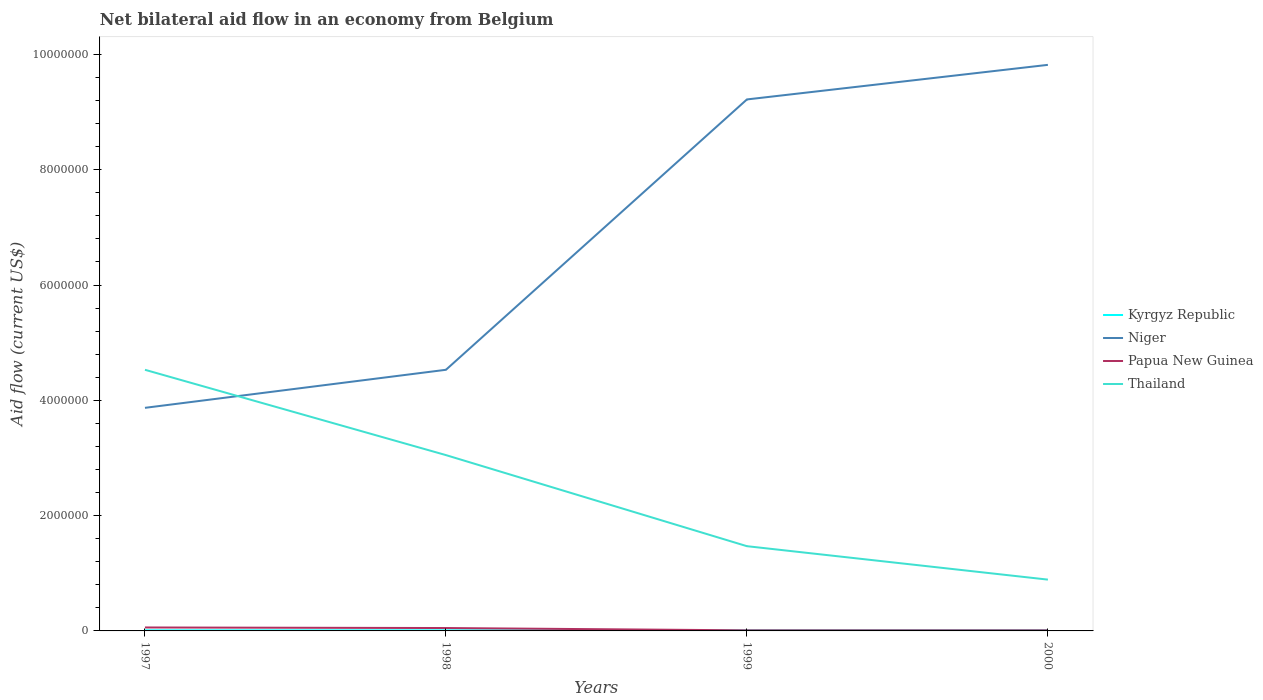How many different coloured lines are there?
Make the answer very short. 4. Is the number of lines equal to the number of legend labels?
Offer a very short reply. Yes. Across all years, what is the maximum net bilateral aid flow in Thailand?
Your answer should be very brief. 8.90e+05. Is the net bilateral aid flow in Niger strictly greater than the net bilateral aid flow in Thailand over the years?
Ensure brevity in your answer.  No. How many lines are there?
Your answer should be compact. 4. How many legend labels are there?
Provide a succinct answer. 4. What is the title of the graph?
Ensure brevity in your answer.  Net bilateral aid flow in an economy from Belgium. Does "Uzbekistan" appear as one of the legend labels in the graph?
Keep it short and to the point. No. What is the label or title of the Y-axis?
Offer a terse response. Aid flow (current US$). What is the Aid flow (current US$) in Niger in 1997?
Keep it short and to the point. 3.87e+06. What is the Aid flow (current US$) of Papua New Guinea in 1997?
Make the answer very short. 6.00e+04. What is the Aid flow (current US$) of Thailand in 1997?
Your answer should be compact. 4.53e+06. What is the Aid flow (current US$) of Kyrgyz Republic in 1998?
Give a very brief answer. 10000. What is the Aid flow (current US$) of Niger in 1998?
Keep it short and to the point. 4.53e+06. What is the Aid flow (current US$) of Thailand in 1998?
Keep it short and to the point. 3.05e+06. What is the Aid flow (current US$) of Kyrgyz Republic in 1999?
Keep it short and to the point. 10000. What is the Aid flow (current US$) in Niger in 1999?
Your response must be concise. 9.22e+06. What is the Aid flow (current US$) in Papua New Guinea in 1999?
Provide a succinct answer. 10000. What is the Aid flow (current US$) of Thailand in 1999?
Give a very brief answer. 1.47e+06. What is the Aid flow (current US$) in Kyrgyz Republic in 2000?
Your response must be concise. 10000. What is the Aid flow (current US$) of Niger in 2000?
Offer a terse response. 9.82e+06. What is the Aid flow (current US$) in Papua New Guinea in 2000?
Offer a terse response. 10000. What is the Aid flow (current US$) of Thailand in 2000?
Give a very brief answer. 8.90e+05. Across all years, what is the maximum Aid flow (current US$) of Niger?
Offer a very short reply. 9.82e+06. Across all years, what is the maximum Aid flow (current US$) of Papua New Guinea?
Provide a short and direct response. 6.00e+04. Across all years, what is the maximum Aid flow (current US$) in Thailand?
Make the answer very short. 4.53e+06. Across all years, what is the minimum Aid flow (current US$) of Niger?
Ensure brevity in your answer.  3.87e+06. Across all years, what is the minimum Aid flow (current US$) in Thailand?
Offer a terse response. 8.90e+05. What is the total Aid flow (current US$) of Kyrgyz Republic in the graph?
Keep it short and to the point. 4.00e+04. What is the total Aid flow (current US$) of Niger in the graph?
Provide a short and direct response. 2.74e+07. What is the total Aid flow (current US$) in Thailand in the graph?
Offer a very short reply. 9.94e+06. What is the difference between the Aid flow (current US$) in Niger in 1997 and that in 1998?
Make the answer very short. -6.60e+05. What is the difference between the Aid flow (current US$) of Thailand in 1997 and that in 1998?
Make the answer very short. 1.48e+06. What is the difference between the Aid flow (current US$) in Kyrgyz Republic in 1997 and that in 1999?
Provide a succinct answer. 0. What is the difference between the Aid flow (current US$) of Niger in 1997 and that in 1999?
Make the answer very short. -5.35e+06. What is the difference between the Aid flow (current US$) of Papua New Guinea in 1997 and that in 1999?
Your response must be concise. 5.00e+04. What is the difference between the Aid flow (current US$) of Thailand in 1997 and that in 1999?
Offer a terse response. 3.06e+06. What is the difference between the Aid flow (current US$) in Kyrgyz Republic in 1997 and that in 2000?
Provide a short and direct response. 0. What is the difference between the Aid flow (current US$) of Niger in 1997 and that in 2000?
Provide a short and direct response. -5.95e+06. What is the difference between the Aid flow (current US$) in Papua New Guinea in 1997 and that in 2000?
Make the answer very short. 5.00e+04. What is the difference between the Aid flow (current US$) in Thailand in 1997 and that in 2000?
Ensure brevity in your answer.  3.64e+06. What is the difference between the Aid flow (current US$) in Kyrgyz Republic in 1998 and that in 1999?
Provide a short and direct response. 0. What is the difference between the Aid flow (current US$) in Niger in 1998 and that in 1999?
Offer a very short reply. -4.69e+06. What is the difference between the Aid flow (current US$) in Thailand in 1998 and that in 1999?
Provide a succinct answer. 1.58e+06. What is the difference between the Aid flow (current US$) in Niger in 1998 and that in 2000?
Your response must be concise. -5.29e+06. What is the difference between the Aid flow (current US$) in Papua New Guinea in 1998 and that in 2000?
Your response must be concise. 4.00e+04. What is the difference between the Aid flow (current US$) of Thailand in 1998 and that in 2000?
Keep it short and to the point. 2.16e+06. What is the difference between the Aid flow (current US$) in Niger in 1999 and that in 2000?
Keep it short and to the point. -6.00e+05. What is the difference between the Aid flow (current US$) of Papua New Guinea in 1999 and that in 2000?
Keep it short and to the point. 0. What is the difference between the Aid flow (current US$) of Thailand in 1999 and that in 2000?
Offer a terse response. 5.80e+05. What is the difference between the Aid flow (current US$) of Kyrgyz Republic in 1997 and the Aid flow (current US$) of Niger in 1998?
Provide a short and direct response. -4.52e+06. What is the difference between the Aid flow (current US$) in Kyrgyz Republic in 1997 and the Aid flow (current US$) in Papua New Guinea in 1998?
Give a very brief answer. -4.00e+04. What is the difference between the Aid flow (current US$) in Kyrgyz Republic in 1997 and the Aid flow (current US$) in Thailand in 1998?
Your response must be concise. -3.04e+06. What is the difference between the Aid flow (current US$) in Niger in 1997 and the Aid flow (current US$) in Papua New Guinea in 1998?
Your answer should be compact. 3.82e+06. What is the difference between the Aid flow (current US$) in Niger in 1997 and the Aid flow (current US$) in Thailand in 1998?
Give a very brief answer. 8.20e+05. What is the difference between the Aid flow (current US$) in Papua New Guinea in 1997 and the Aid flow (current US$) in Thailand in 1998?
Your answer should be compact. -2.99e+06. What is the difference between the Aid flow (current US$) of Kyrgyz Republic in 1997 and the Aid flow (current US$) of Niger in 1999?
Your response must be concise. -9.21e+06. What is the difference between the Aid flow (current US$) of Kyrgyz Republic in 1997 and the Aid flow (current US$) of Thailand in 1999?
Your answer should be compact. -1.46e+06. What is the difference between the Aid flow (current US$) of Niger in 1997 and the Aid flow (current US$) of Papua New Guinea in 1999?
Your answer should be very brief. 3.86e+06. What is the difference between the Aid flow (current US$) of Niger in 1997 and the Aid flow (current US$) of Thailand in 1999?
Provide a succinct answer. 2.40e+06. What is the difference between the Aid flow (current US$) of Papua New Guinea in 1997 and the Aid flow (current US$) of Thailand in 1999?
Your response must be concise. -1.41e+06. What is the difference between the Aid flow (current US$) in Kyrgyz Republic in 1997 and the Aid flow (current US$) in Niger in 2000?
Give a very brief answer. -9.81e+06. What is the difference between the Aid flow (current US$) of Kyrgyz Republic in 1997 and the Aid flow (current US$) of Thailand in 2000?
Your response must be concise. -8.80e+05. What is the difference between the Aid flow (current US$) of Niger in 1997 and the Aid flow (current US$) of Papua New Guinea in 2000?
Ensure brevity in your answer.  3.86e+06. What is the difference between the Aid flow (current US$) of Niger in 1997 and the Aid flow (current US$) of Thailand in 2000?
Provide a succinct answer. 2.98e+06. What is the difference between the Aid flow (current US$) of Papua New Guinea in 1997 and the Aid flow (current US$) of Thailand in 2000?
Make the answer very short. -8.30e+05. What is the difference between the Aid flow (current US$) of Kyrgyz Republic in 1998 and the Aid flow (current US$) of Niger in 1999?
Offer a terse response. -9.21e+06. What is the difference between the Aid flow (current US$) of Kyrgyz Republic in 1998 and the Aid flow (current US$) of Thailand in 1999?
Your answer should be compact. -1.46e+06. What is the difference between the Aid flow (current US$) in Niger in 1998 and the Aid flow (current US$) in Papua New Guinea in 1999?
Provide a succinct answer. 4.52e+06. What is the difference between the Aid flow (current US$) in Niger in 1998 and the Aid flow (current US$) in Thailand in 1999?
Your answer should be compact. 3.06e+06. What is the difference between the Aid flow (current US$) in Papua New Guinea in 1998 and the Aid flow (current US$) in Thailand in 1999?
Make the answer very short. -1.42e+06. What is the difference between the Aid flow (current US$) in Kyrgyz Republic in 1998 and the Aid flow (current US$) in Niger in 2000?
Your answer should be very brief. -9.81e+06. What is the difference between the Aid flow (current US$) of Kyrgyz Republic in 1998 and the Aid flow (current US$) of Thailand in 2000?
Provide a succinct answer. -8.80e+05. What is the difference between the Aid flow (current US$) in Niger in 1998 and the Aid flow (current US$) in Papua New Guinea in 2000?
Your answer should be compact. 4.52e+06. What is the difference between the Aid flow (current US$) of Niger in 1998 and the Aid flow (current US$) of Thailand in 2000?
Your answer should be compact. 3.64e+06. What is the difference between the Aid flow (current US$) in Papua New Guinea in 1998 and the Aid flow (current US$) in Thailand in 2000?
Provide a short and direct response. -8.40e+05. What is the difference between the Aid flow (current US$) in Kyrgyz Republic in 1999 and the Aid flow (current US$) in Niger in 2000?
Give a very brief answer. -9.81e+06. What is the difference between the Aid flow (current US$) of Kyrgyz Republic in 1999 and the Aid flow (current US$) of Thailand in 2000?
Give a very brief answer. -8.80e+05. What is the difference between the Aid flow (current US$) in Niger in 1999 and the Aid flow (current US$) in Papua New Guinea in 2000?
Provide a succinct answer. 9.21e+06. What is the difference between the Aid flow (current US$) of Niger in 1999 and the Aid flow (current US$) of Thailand in 2000?
Your answer should be very brief. 8.33e+06. What is the difference between the Aid flow (current US$) of Papua New Guinea in 1999 and the Aid flow (current US$) of Thailand in 2000?
Offer a very short reply. -8.80e+05. What is the average Aid flow (current US$) of Kyrgyz Republic per year?
Your answer should be compact. 10000. What is the average Aid flow (current US$) of Niger per year?
Offer a terse response. 6.86e+06. What is the average Aid flow (current US$) of Papua New Guinea per year?
Your answer should be very brief. 3.25e+04. What is the average Aid flow (current US$) of Thailand per year?
Provide a short and direct response. 2.48e+06. In the year 1997, what is the difference between the Aid flow (current US$) in Kyrgyz Republic and Aid flow (current US$) in Niger?
Your response must be concise. -3.86e+06. In the year 1997, what is the difference between the Aid flow (current US$) in Kyrgyz Republic and Aid flow (current US$) in Thailand?
Keep it short and to the point. -4.52e+06. In the year 1997, what is the difference between the Aid flow (current US$) in Niger and Aid flow (current US$) in Papua New Guinea?
Your response must be concise. 3.81e+06. In the year 1997, what is the difference between the Aid flow (current US$) of Niger and Aid flow (current US$) of Thailand?
Your response must be concise. -6.60e+05. In the year 1997, what is the difference between the Aid flow (current US$) of Papua New Guinea and Aid flow (current US$) of Thailand?
Make the answer very short. -4.47e+06. In the year 1998, what is the difference between the Aid flow (current US$) of Kyrgyz Republic and Aid flow (current US$) of Niger?
Make the answer very short. -4.52e+06. In the year 1998, what is the difference between the Aid flow (current US$) in Kyrgyz Republic and Aid flow (current US$) in Papua New Guinea?
Provide a short and direct response. -4.00e+04. In the year 1998, what is the difference between the Aid flow (current US$) in Kyrgyz Republic and Aid flow (current US$) in Thailand?
Your response must be concise. -3.04e+06. In the year 1998, what is the difference between the Aid flow (current US$) of Niger and Aid flow (current US$) of Papua New Guinea?
Your answer should be very brief. 4.48e+06. In the year 1998, what is the difference between the Aid flow (current US$) of Niger and Aid flow (current US$) of Thailand?
Keep it short and to the point. 1.48e+06. In the year 1998, what is the difference between the Aid flow (current US$) in Papua New Guinea and Aid flow (current US$) in Thailand?
Your answer should be compact. -3.00e+06. In the year 1999, what is the difference between the Aid flow (current US$) in Kyrgyz Republic and Aid flow (current US$) in Niger?
Offer a very short reply. -9.21e+06. In the year 1999, what is the difference between the Aid flow (current US$) in Kyrgyz Republic and Aid flow (current US$) in Papua New Guinea?
Ensure brevity in your answer.  0. In the year 1999, what is the difference between the Aid flow (current US$) in Kyrgyz Republic and Aid flow (current US$) in Thailand?
Keep it short and to the point. -1.46e+06. In the year 1999, what is the difference between the Aid flow (current US$) of Niger and Aid flow (current US$) of Papua New Guinea?
Offer a very short reply. 9.21e+06. In the year 1999, what is the difference between the Aid flow (current US$) of Niger and Aid flow (current US$) of Thailand?
Provide a succinct answer. 7.75e+06. In the year 1999, what is the difference between the Aid flow (current US$) in Papua New Guinea and Aid flow (current US$) in Thailand?
Ensure brevity in your answer.  -1.46e+06. In the year 2000, what is the difference between the Aid flow (current US$) of Kyrgyz Republic and Aid flow (current US$) of Niger?
Make the answer very short. -9.81e+06. In the year 2000, what is the difference between the Aid flow (current US$) of Kyrgyz Republic and Aid flow (current US$) of Thailand?
Give a very brief answer. -8.80e+05. In the year 2000, what is the difference between the Aid flow (current US$) in Niger and Aid flow (current US$) in Papua New Guinea?
Make the answer very short. 9.81e+06. In the year 2000, what is the difference between the Aid flow (current US$) of Niger and Aid flow (current US$) of Thailand?
Your answer should be compact. 8.93e+06. In the year 2000, what is the difference between the Aid flow (current US$) of Papua New Guinea and Aid flow (current US$) of Thailand?
Offer a terse response. -8.80e+05. What is the ratio of the Aid flow (current US$) of Kyrgyz Republic in 1997 to that in 1998?
Offer a very short reply. 1. What is the ratio of the Aid flow (current US$) in Niger in 1997 to that in 1998?
Provide a succinct answer. 0.85. What is the ratio of the Aid flow (current US$) in Thailand in 1997 to that in 1998?
Your answer should be very brief. 1.49. What is the ratio of the Aid flow (current US$) in Kyrgyz Republic in 1997 to that in 1999?
Provide a short and direct response. 1. What is the ratio of the Aid flow (current US$) of Niger in 1997 to that in 1999?
Your answer should be very brief. 0.42. What is the ratio of the Aid flow (current US$) of Thailand in 1997 to that in 1999?
Keep it short and to the point. 3.08. What is the ratio of the Aid flow (current US$) in Niger in 1997 to that in 2000?
Offer a terse response. 0.39. What is the ratio of the Aid flow (current US$) in Thailand in 1997 to that in 2000?
Make the answer very short. 5.09. What is the ratio of the Aid flow (current US$) of Kyrgyz Republic in 1998 to that in 1999?
Your response must be concise. 1. What is the ratio of the Aid flow (current US$) of Niger in 1998 to that in 1999?
Provide a short and direct response. 0.49. What is the ratio of the Aid flow (current US$) in Papua New Guinea in 1998 to that in 1999?
Make the answer very short. 5. What is the ratio of the Aid flow (current US$) in Thailand in 1998 to that in 1999?
Ensure brevity in your answer.  2.07. What is the ratio of the Aid flow (current US$) in Niger in 1998 to that in 2000?
Provide a succinct answer. 0.46. What is the ratio of the Aid flow (current US$) in Thailand in 1998 to that in 2000?
Ensure brevity in your answer.  3.43. What is the ratio of the Aid flow (current US$) in Niger in 1999 to that in 2000?
Offer a terse response. 0.94. What is the ratio of the Aid flow (current US$) in Thailand in 1999 to that in 2000?
Keep it short and to the point. 1.65. What is the difference between the highest and the second highest Aid flow (current US$) of Kyrgyz Republic?
Give a very brief answer. 0. What is the difference between the highest and the second highest Aid flow (current US$) of Thailand?
Provide a succinct answer. 1.48e+06. What is the difference between the highest and the lowest Aid flow (current US$) in Kyrgyz Republic?
Keep it short and to the point. 0. What is the difference between the highest and the lowest Aid flow (current US$) of Niger?
Your answer should be compact. 5.95e+06. What is the difference between the highest and the lowest Aid flow (current US$) of Thailand?
Give a very brief answer. 3.64e+06. 